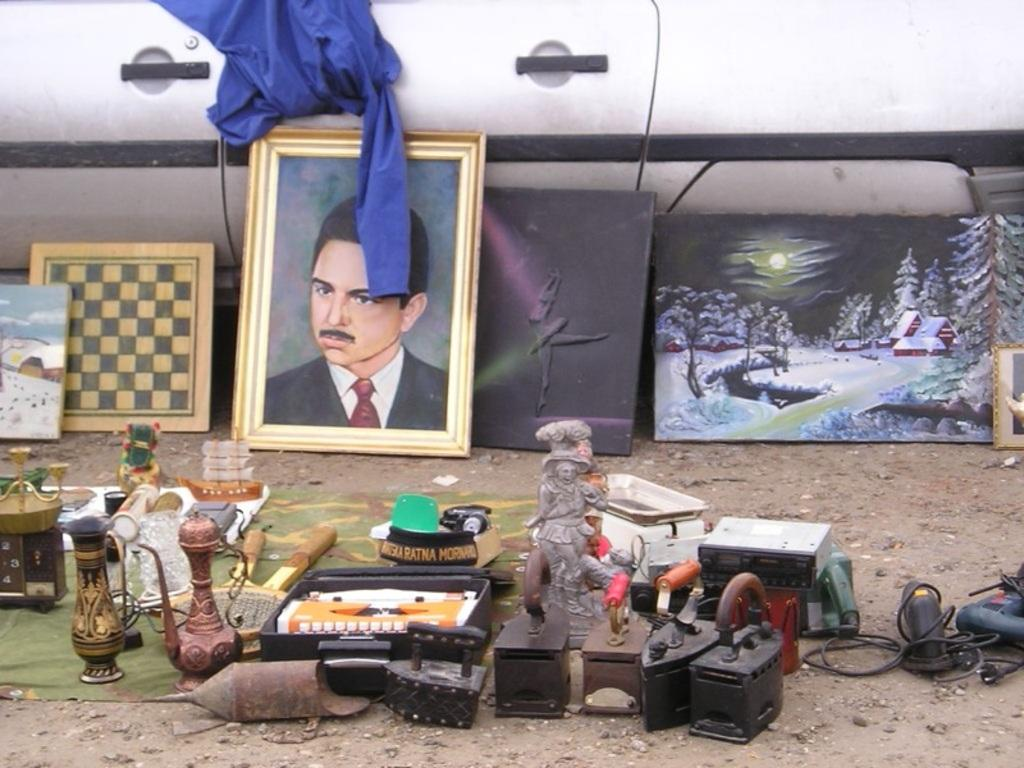What can be seen in the foreground area of the image? There are objects in the foreground area of the image. What can be seen in the background of the image? There are frames and other items in the background of the image. Who is the owner of the trees in the image? There are no trees present in the image. What type of insurance is required for the items in the image? The question of insurance is not relevant to the image, as it does not contain any items that would require insurance. 